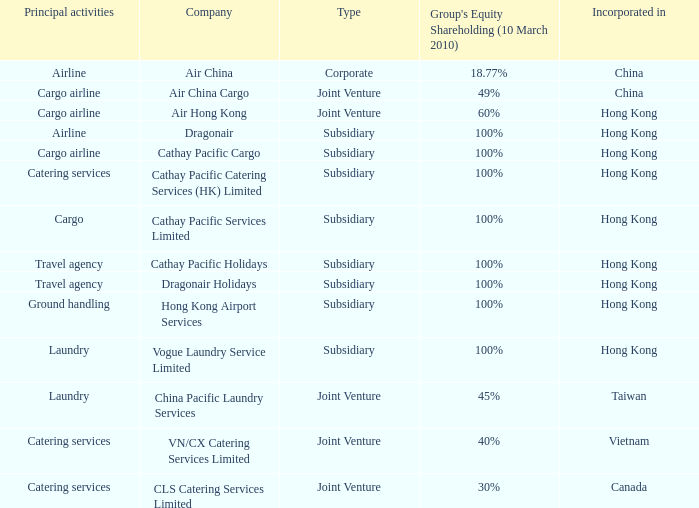What is the type for the Cathay Pacific Holidays company, an incorporation of Hong Kong and listed activities as Travel Agency? Subsidiary. Would you mind parsing the complete table? {'header': ['Principal activities', 'Company', 'Type', "Group's Equity Shareholding (10 March 2010)", 'Incorporated in'], 'rows': [['Airline', 'Air China', 'Corporate', '18.77%', 'China'], ['Cargo airline', 'Air China Cargo', 'Joint Venture', '49%', 'China'], ['Cargo airline', 'Air Hong Kong', 'Joint Venture', '60%', 'Hong Kong'], ['Airline', 'Dragonair', 'Subsidiary', '100%', 'Hong Kong'], ['Cargo airline', 'Cathay Pacific Cargo', 'Subsidiary', '100%', 'Hong Kong'], ['Catering services', 'Cathay Pacific Catering Services (HK) Limited', 'Subsidiary', '100%', 'Hong Kong'], ['Cargo', 'Cathay Pacific Services Limited', 'Subsidiary', '100%', 'Hong Kong'], ['Travel agency', 'Cathay Pacific Holidays', 'Subsidiary', '100%', 'Hong Kong'], ['Travel agency', 'Dragonair Holidays', 'Subsidiary', '100%', 'Hong Kong'], ['Ground handling', 'Hong Kong Airport Services', 'Subsidiary', '100%', 'Hong Kong'], ['Laundry', 'Vogue Laundry Service Limited', 'Subsidiary', '100%', 'Hong Kong'], ['Laundry', 'China Pacific Laundry Services', 'Joint Venture', '45%', 'Taiwan'], ['Catering services', 'VN/CX Catering Services Limited', 'Joint Venture', '40%', 'Vietnam'], ['Catering services', 'CLS Catering Services Limited', 'Joint Venture', '30%', 'Canada']]} 